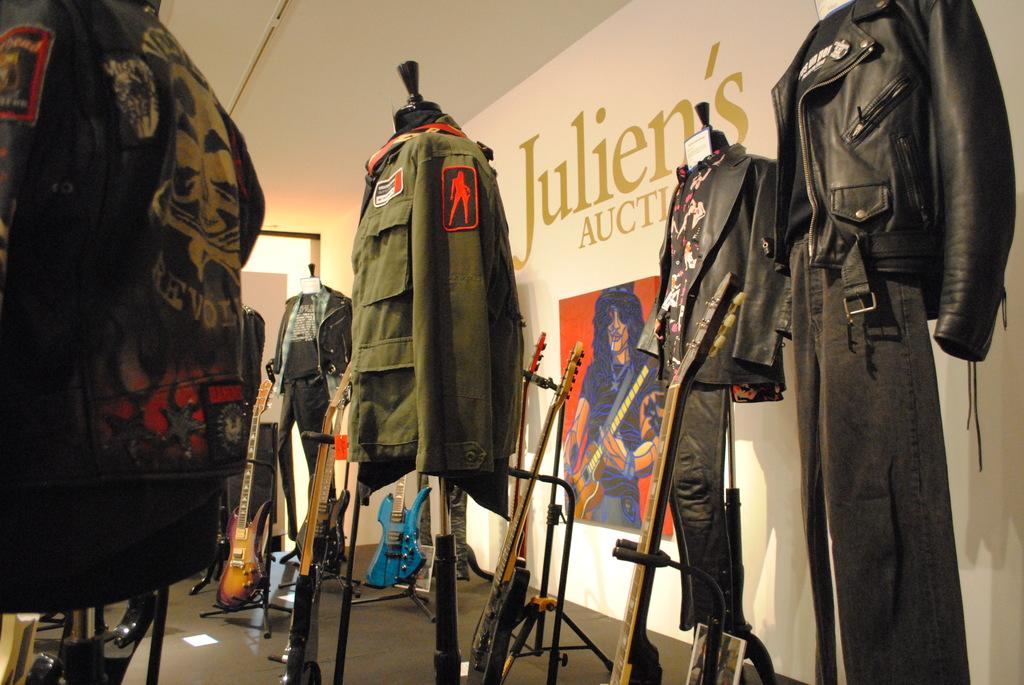What objects are on the floor in the image? There are lots of clothes and guitars on the floor. What else can be seen on the floor besides clothes and guitars? There are stands on the floor. What is visible on the wall behind the stands? There is a photo frame on the wall behind the stands. What type of attack is being carried out by the flesh in the image? There is no flesh or attack present in the image. 